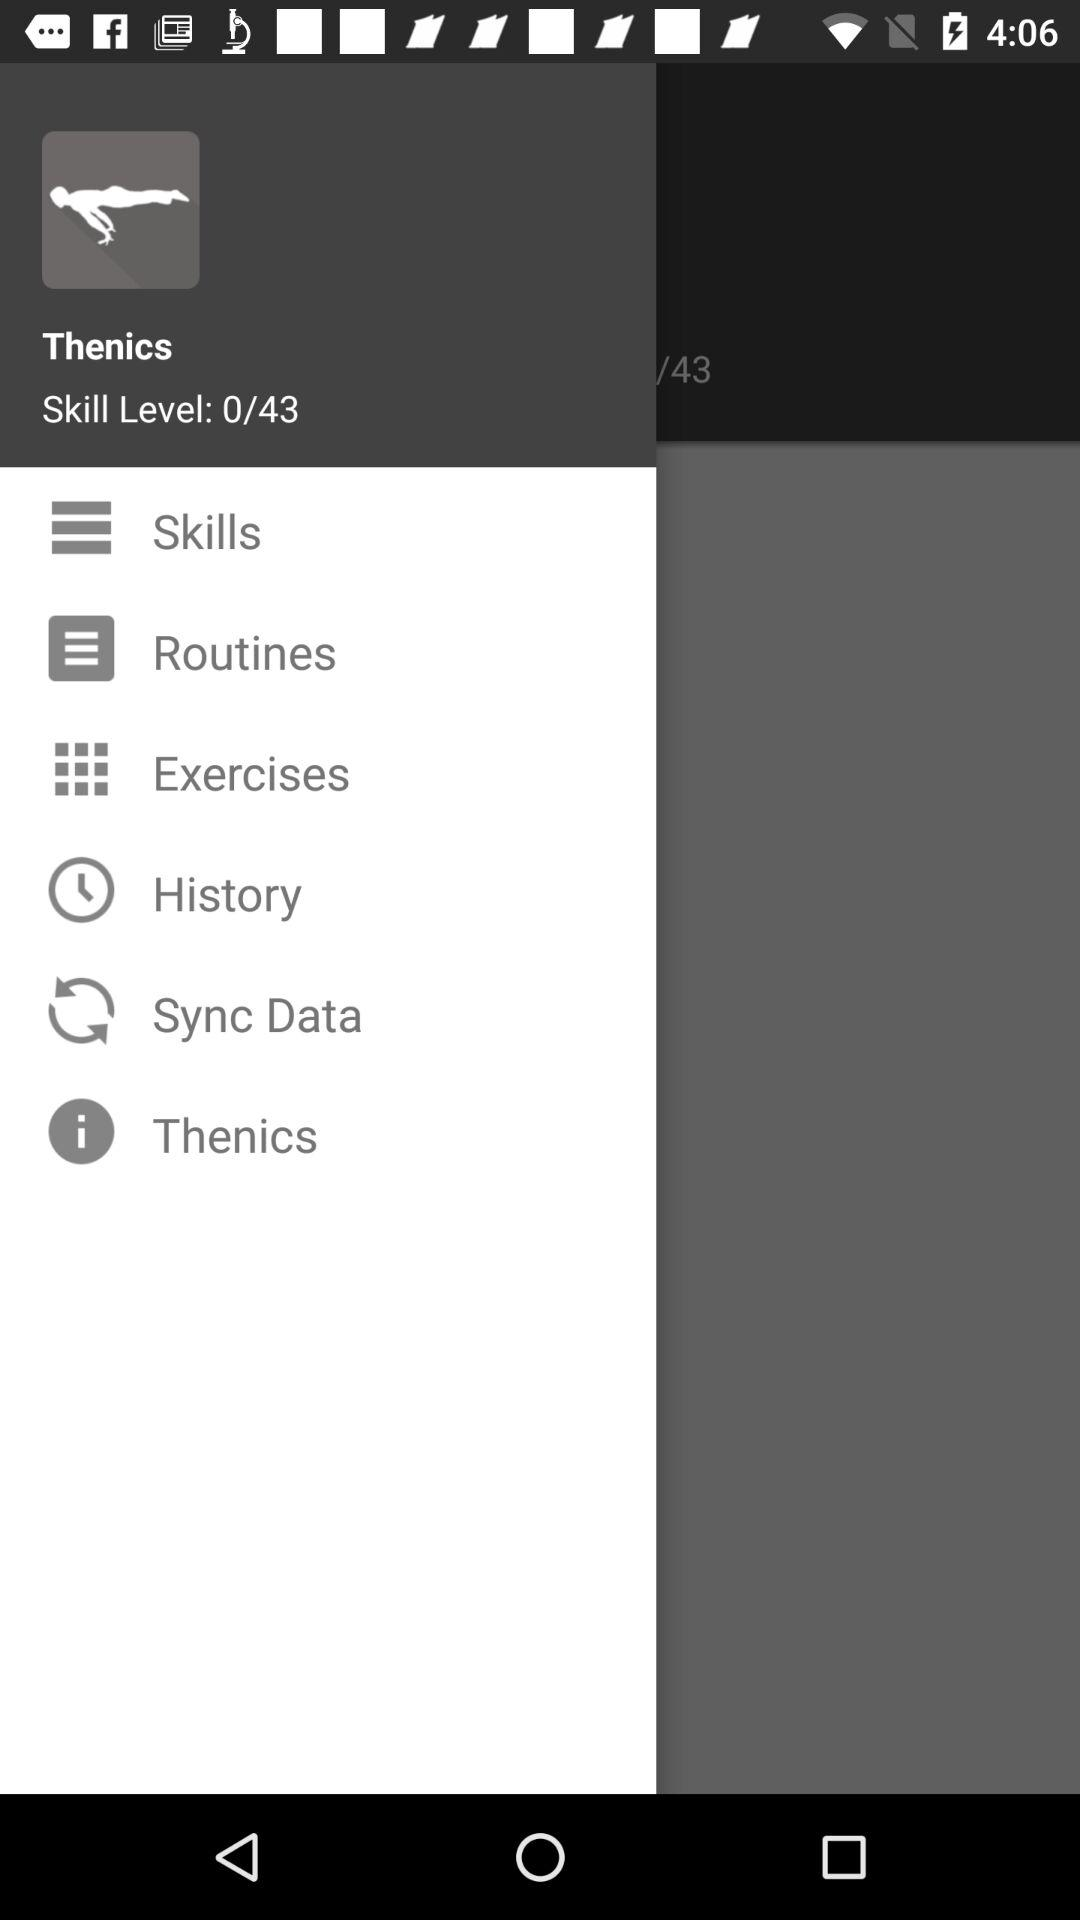What is the total count of skill levels? The total count of skill levels is 43. 